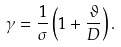<formula> <loc_0><loc_0><loc_500><loc_500>\gamma = \frac { 1 } { \sigma } \left ( 1 + \frac { \vartheta } { D } \right ) .</formula> 